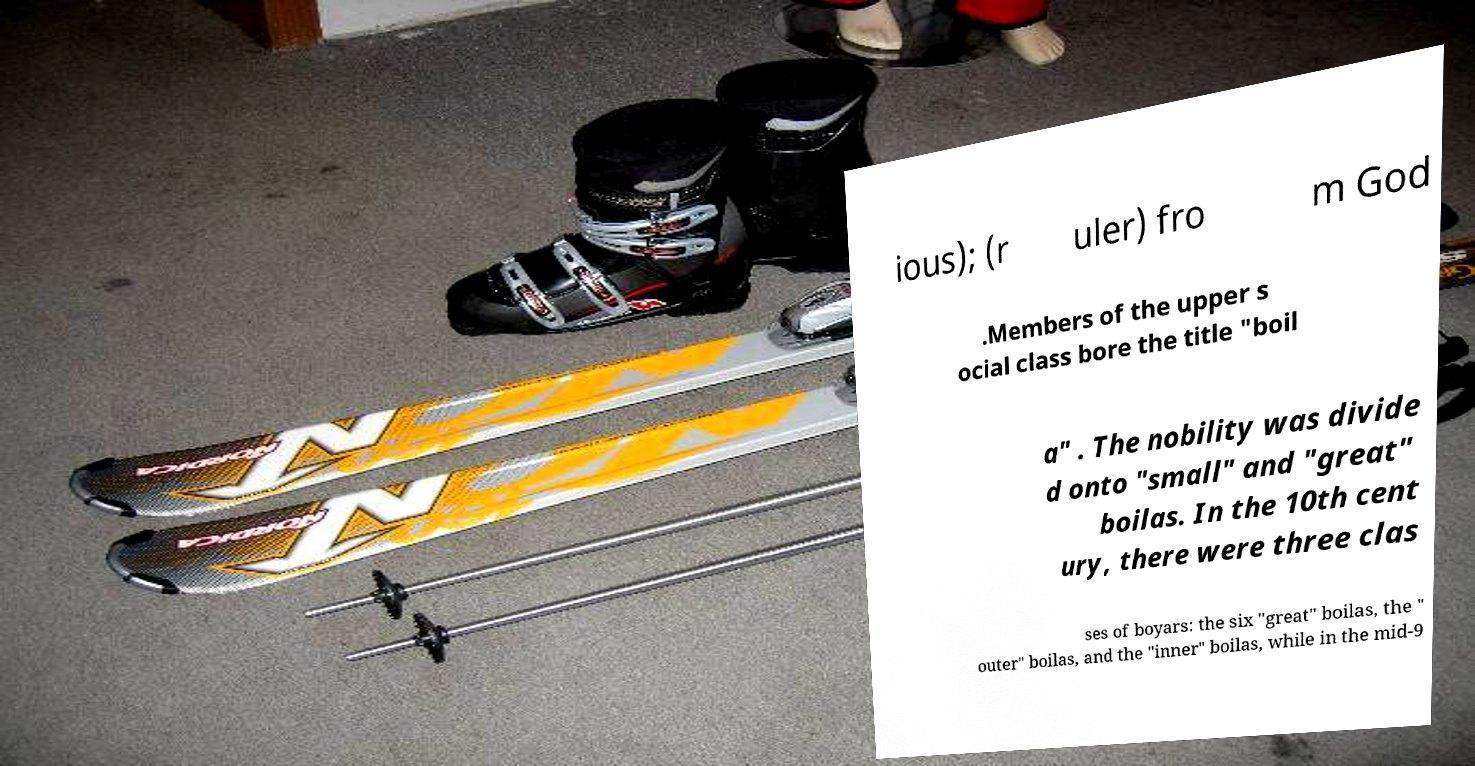I need the written content from this picture converted into text. Can you do that? ious); (r uler) fro m God .Members of the upper s ocial class bore the title "boil a" . The nobility was divide d onto "small" and "great" boilas. In the 10th cent ury, there were three clas ses of boyars: the six "great" boilas, the " outer" boilas, and the "inner" boilas, while in the mid-9 